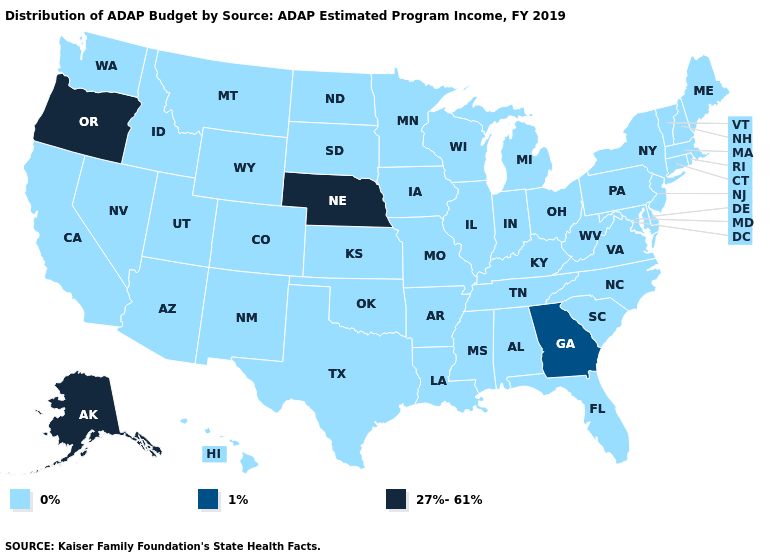How many symbols are there in the legend?
Give a very brief answer. 3. What is the value of Indiana?
Short answer required. 0%. Name the states that have a value in the range 27%-61%?
Give a very brief answer. Alaska, Nebraska, Oregon. Does Connecticut have a lower value than Florida?
Write a very short answer. No. What is the value of Missouri?
Give a very brief answer. 0%. What is the value of Kentucky?
Be succinct. 0%. Name the states that have a value in the range 1%?
Be succinct. Georgia. Name the states that have a value in the range 1%?
Write a very short answer. Georgia. What is the value of Pennsylvania?
Answer briefly. 0%. Which states have the lowest value in the USA?
Be succinct. Alabama, Arizona, Arkansas, California, Colorado, Connecticut, Delaware, Florida, Hawaii, Idaho, Illinois, Indiana, Iowa, Kansas, Kentucky, Louisiana, Maine, Maryland, Massachusetts, Michigan, Minnesota, Mississippi, Missouri, Montana, Nevada, New Hampshire, New Jersey, New Mexico, New York, North Carolina, North Dakota, Ohio, Oklahoma, Pennsylvania, Rhode Island, South Carolina, South Dakota, Tennessee, Texas, Utah, Vermont, Virginia, Washington, West Virginia, Wisconsin, Wyoming. Does Illinois have the lowest value in the MidWest?
Quick response, please. Yes. What is the highest value in states that border New Hampshire?
Quick response, please. 0%. What is the value of California?
Give a very brief answer. 0%. What is the value of Ohio?
Keep it brief. 0%. Among the states that border California , which have the lowest value?
Concise answer only. Arizona, Nevada. 